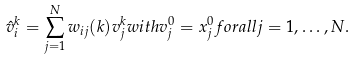Convert formula to latex. <formula><loc_0><loc_0><loc_500><loc_500>\hat { v } _ { i } ^ { k } = \sum _ { j = 1 } ^ { N } w _ { i j } ( k ) v _ { j } ^ { k } w i t h v _ { j } ^ { 0 } = x _ { j } ^ { 0 } f o r a l l j = 1 , \dots , N .</formula> 